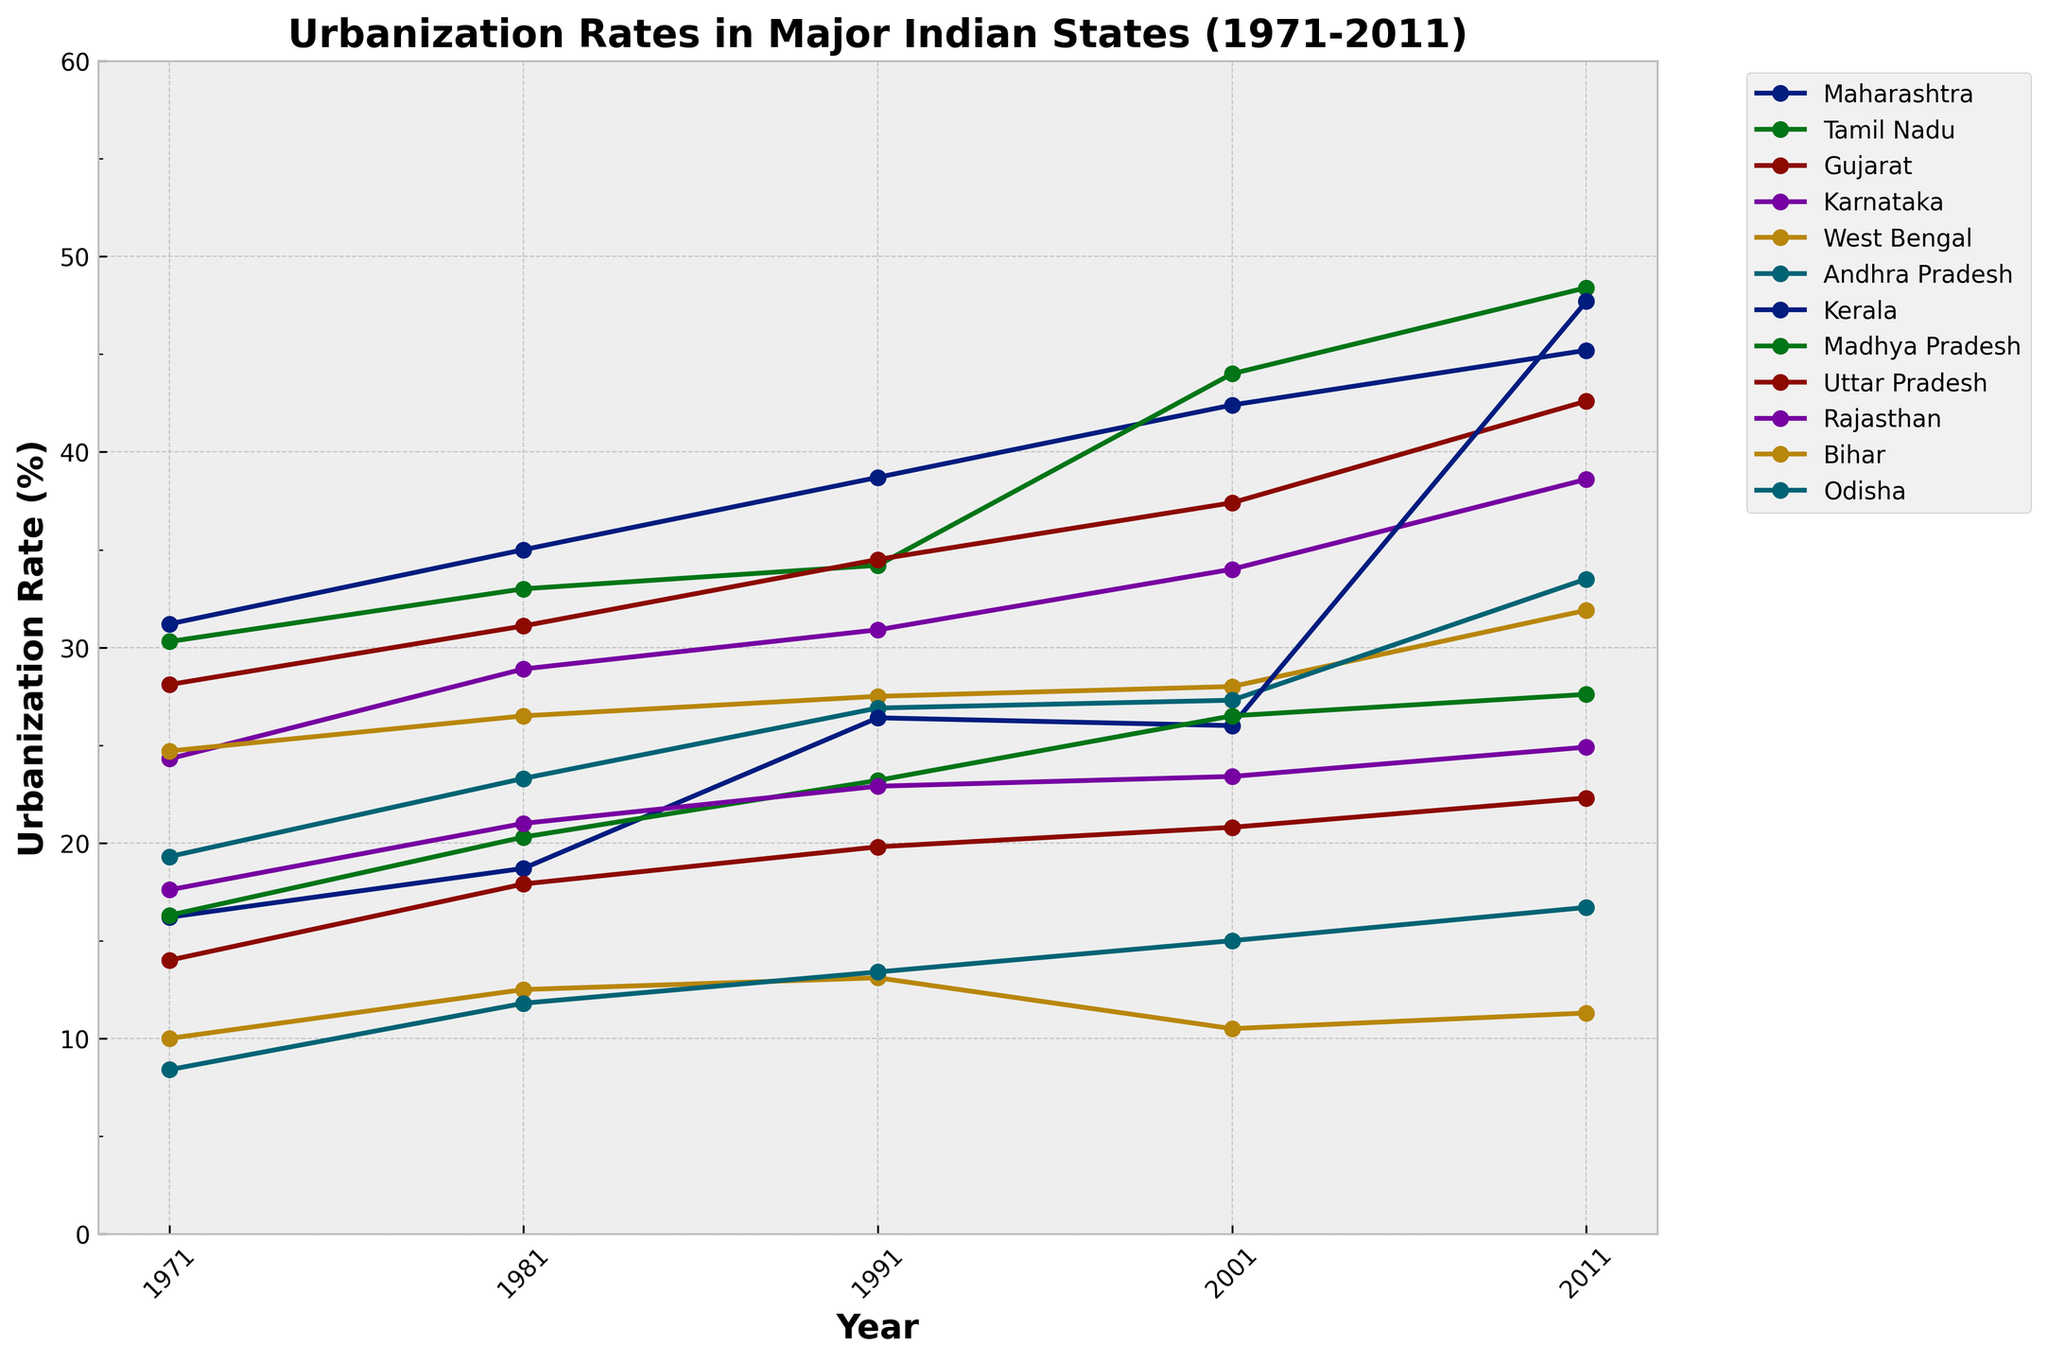What is the urbanization rate of Tamil Nadu in 2011? The urbanization rate for Tamil Nadu can be found by locating Tamil Nadu on the graph and following its corresponding line to the year 2011.
Answer: 48.4% Which state had the lowest urbanization rate in 1971? By identifying the lines representing each state and comparing their positions for the year 1971, Odisha is seen at the lowest point.
Answer: Odisha Between which years did Kerala see the largest increase in its urbanization rate? By examining the line for Kerala and comparing changes between consecutive years, the largest increase is between 2001 and 2011, where the rate jumps from 26.0% to 47.7%.
Answer: 2001 and 2011 How does the urbanization rate of Maharashtra in 1981 compare to that of Gujarat in the same year? By locating both Maharashtra and Gujarat’s lines at the year 1981, you'll see Maharashtra has a higher urbanization rate.
Answer: Maharashtra is higher Calculate the average urbanization rate for Karnataka across all years provided. Sum the urbanization rates for Karnataka (24.3, 28.9, 30.9, 34.0, 38.6), then divide by the number of years (5). The calculation is (24.3 + 28.9 + 30.9 + 34.0 + 38.6) / 5 = 31.34%.
Answer: 31.34% Which state shows a decreasing trend in urbanization rate between any consecutive years? By visually examining all lines for any decreasing segments between consecutive data points, Bihar shows a decrease between 1991 (13.1%) and 2001 (10.5%).
Answer: Bihar What is the difference in urbanization rate between Andhra Pradesh and Uttar Pradesh in 1991? Locate the urbanization rates for Andhra Pradesh (26.9%) and Uttar Pradesh (19.8%) for 1991, then compute the difference (26.9% - 19.8% = 7.1%).
Answer: 7.1% Which states crossed the 40% urbanization rate by 2011? Check the lines for each state in 2011 to see which ones exceed the 40% mark, which includes Maharashtra, Tamil Nadu, Gujarat, and Kerala.
Answer: Maharashtra, Tamil Nadu, Gujarat, Kerala What was the urbanization rate trend for West Bengal from 1971 to 2011? Trace the line for West Bengal over the years 1971 to 2011 to see if it generally ascends, descends, or fluctuates. It shows a gradual increase from 24.7% in 1971 to 31.9% in 2011.
Answer: Gradual increase 